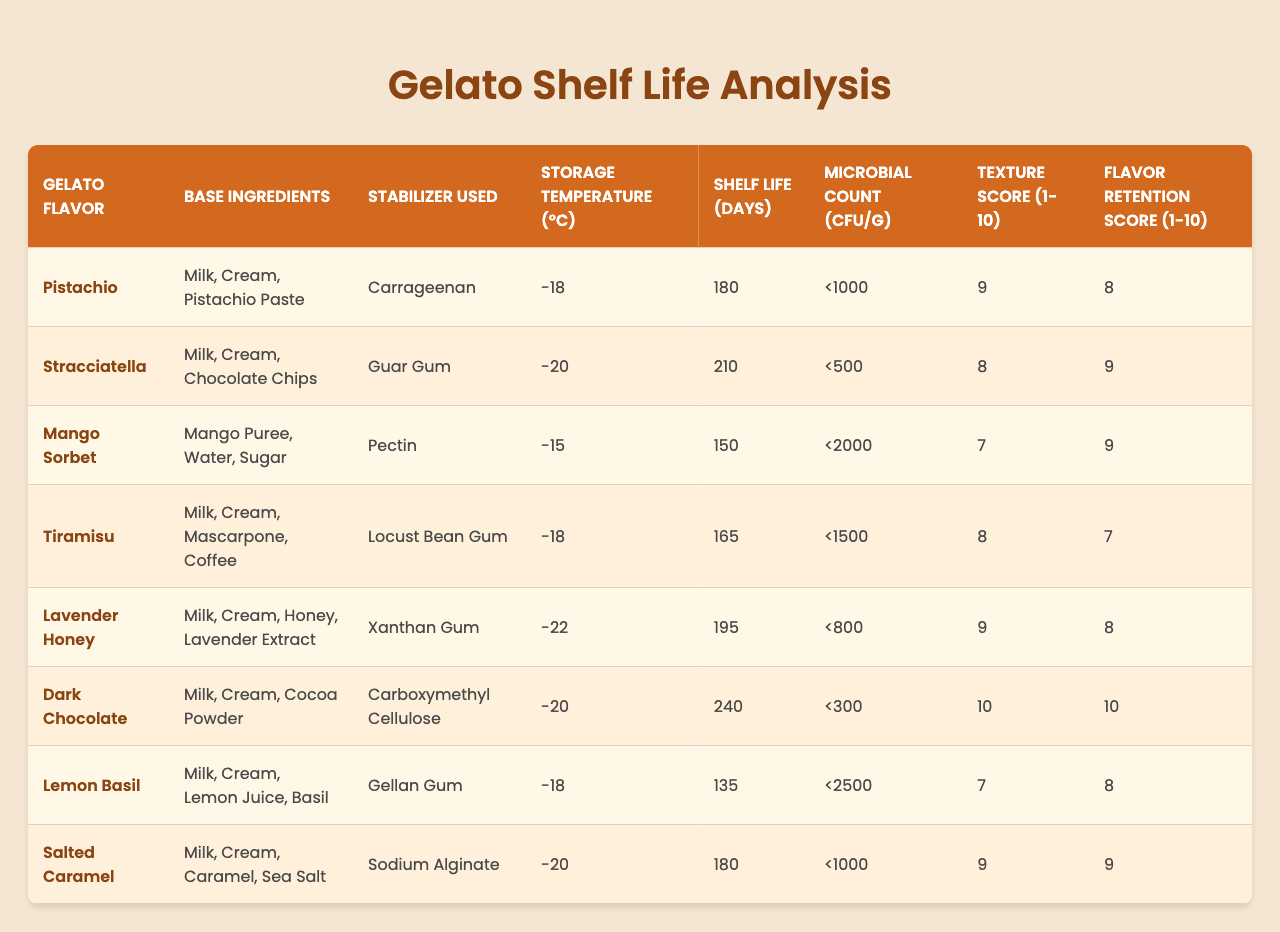What is the shelf life of Dark Chocolate gelato? The table indicates the shelf life for Dark Chocolate gelato is specified in the "Shelf Life (Days)" column, which shows a value of 240 days.
Answer: 240 days Which gelato formulation has the highest microbial count? The microbial count for each formulation is listed in the "Microbial Count (CFU/g)" column. By comparing these values, the Lemon Basil gelato shows the highest count at <2500 CFU/g.
Answer: Lemon Basil Is the flavor retention score for Tiramisu gelato higher than that for Mango Sorbet? The flavor retention scores for Tiramisu and Mango Sorbet are 7 and 9, respectively. Since 7 is not higher than 9, the answer is no.
Answer: No What is the average shelf life of all gelato formulations? The shelf life values are: 180, 210, 150, 165, 195, 240, 135, and 180 days. Summing these gives 1800 days across 8 formulations, so the average is 1800/8 = 225 days.
Answer: 225 days Does the gelato with the lowest storage temperature have the shortest shelf life? The gelato with the lowest storage temperature is Lavender Honey at -22°C, with a shelf life of 195 days. The gelato with the shortest shelf life is Lemon Basil at -18°C, with 135 days. Since 195 days is longer than 135 days, the statement is false.
Answer: No Which stabilizer is used in the Stracciatella formulation? Looking at the "Stabilizer Used" column, Stracciatella is associated with Guar Gum.
Answer: Guar Gum What is the texture score for the Mango Sorbet compared to the Tiramisu gelato? The texture score for Mango Sorbet is 7, while for Tiramisu it is 8. Since 7 is less than 8, Tiramisu has a higher score.
Answer: Tiramisu has a higher score Which gelato formulation requires the lowest storage temperature? The table shows the "Storage Temperature (°C)" for each gelato, and the lowest temperature listed is -22°C for Lavender Honey.
Answer: Lavender Honey Calculate the difference in shelf life between the highest and lowest shelf life gelatos. The highest shelf life is 240 days for Dark Chocolate, and the lowest is 135 days for Lemon Basil. The difference is 240 - 135 = 105 days.
Answer: 105 days Is the texture score for any gelato formulation equal to 10? By examining the "Texture Score (1-10)" column, Dark Chocolate gelato has a score of 10, which confirms that there is at least one formulation with a score of 10.
Answer: Yes 